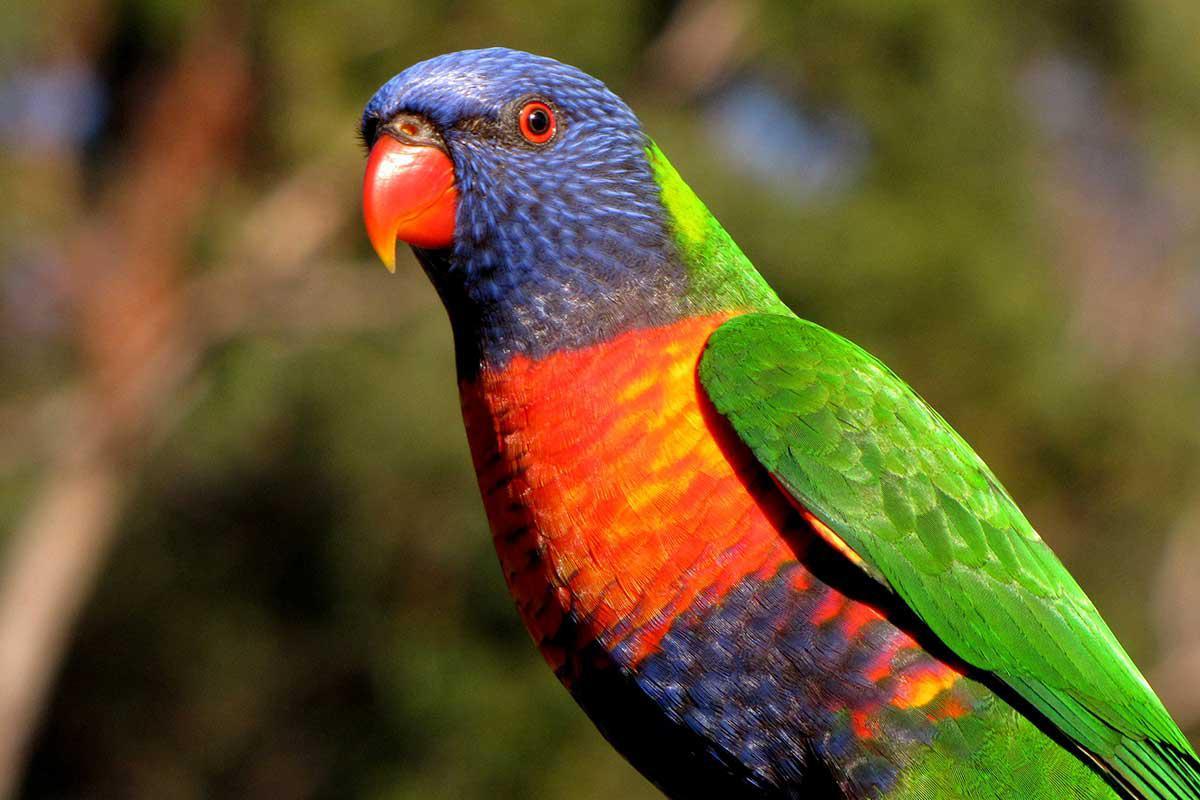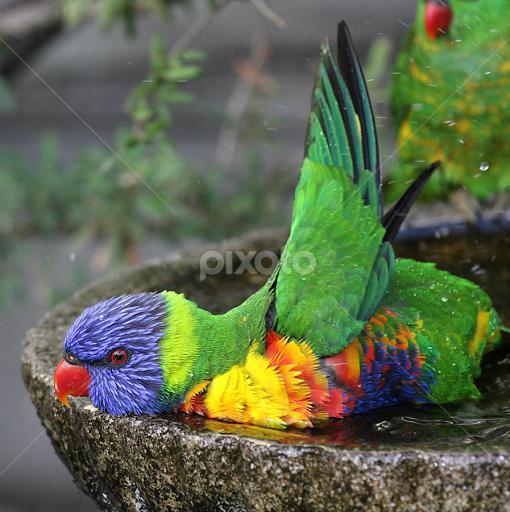The first image is the image on the left, the second image is the image on the right. For the images shown, is this caption "There is no more than two parrots." true? Answer yes or no. Yes. 